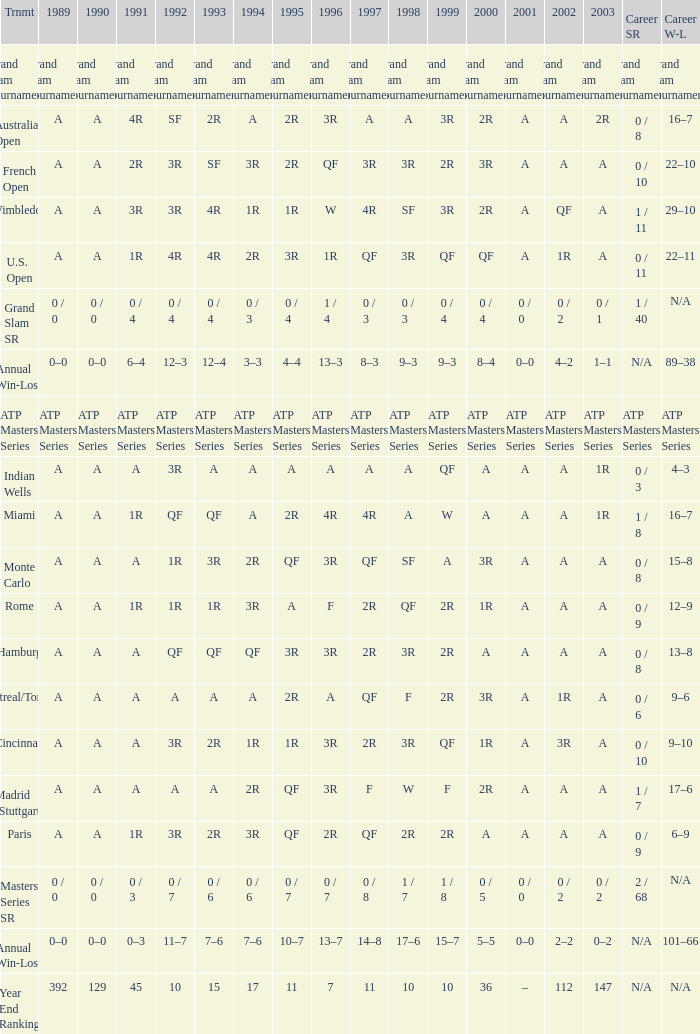What is the value in 1997 when the value in 1989 is A, 1995 is QF, 1996 is 3R and the career SR is 0 / 8? QF. 